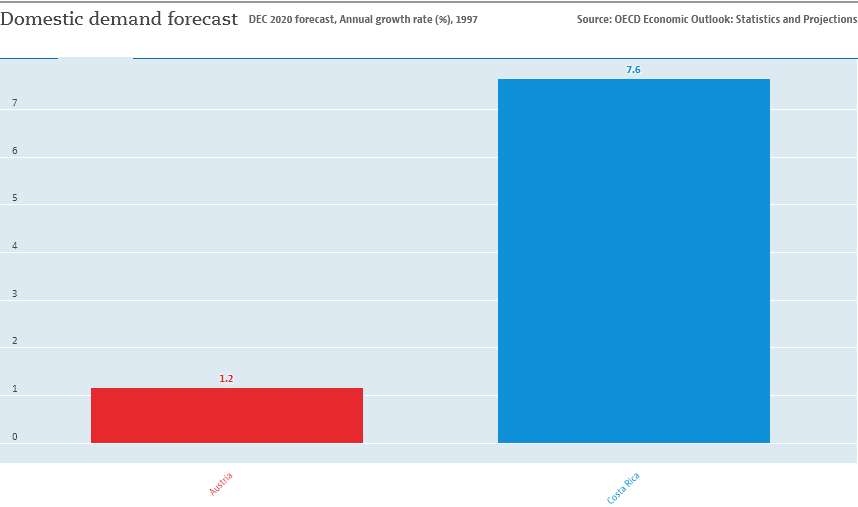Identify some key points in this picture. I would like to find the sum of the two bars in the graph separately, starting from 8.8. The domestic demand forecast in Costa Rica is expected to be 0.076. 